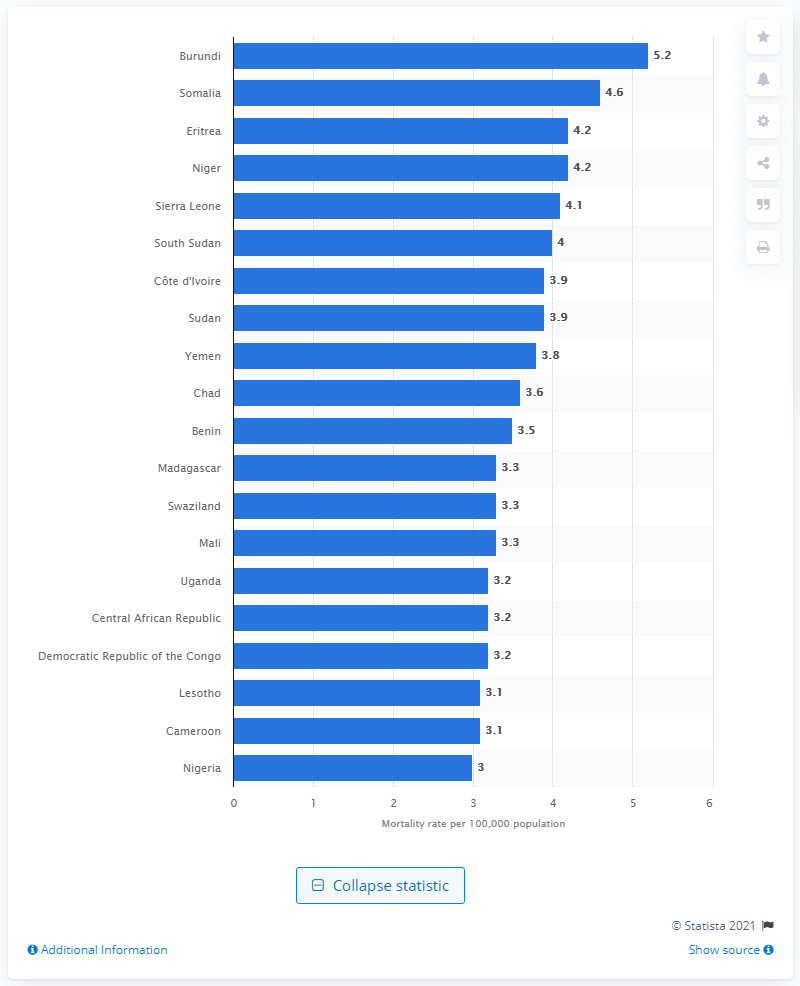Point out several critical features in this image. The unintentional poisoning mortality rate in Burundi in 2016 was 5.2. 